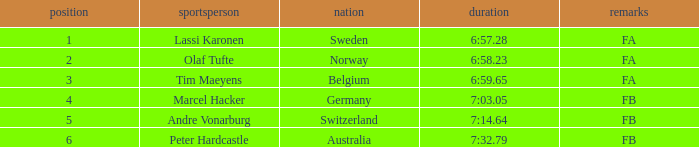Which athlete is from Norway? Olaf Tufte. 